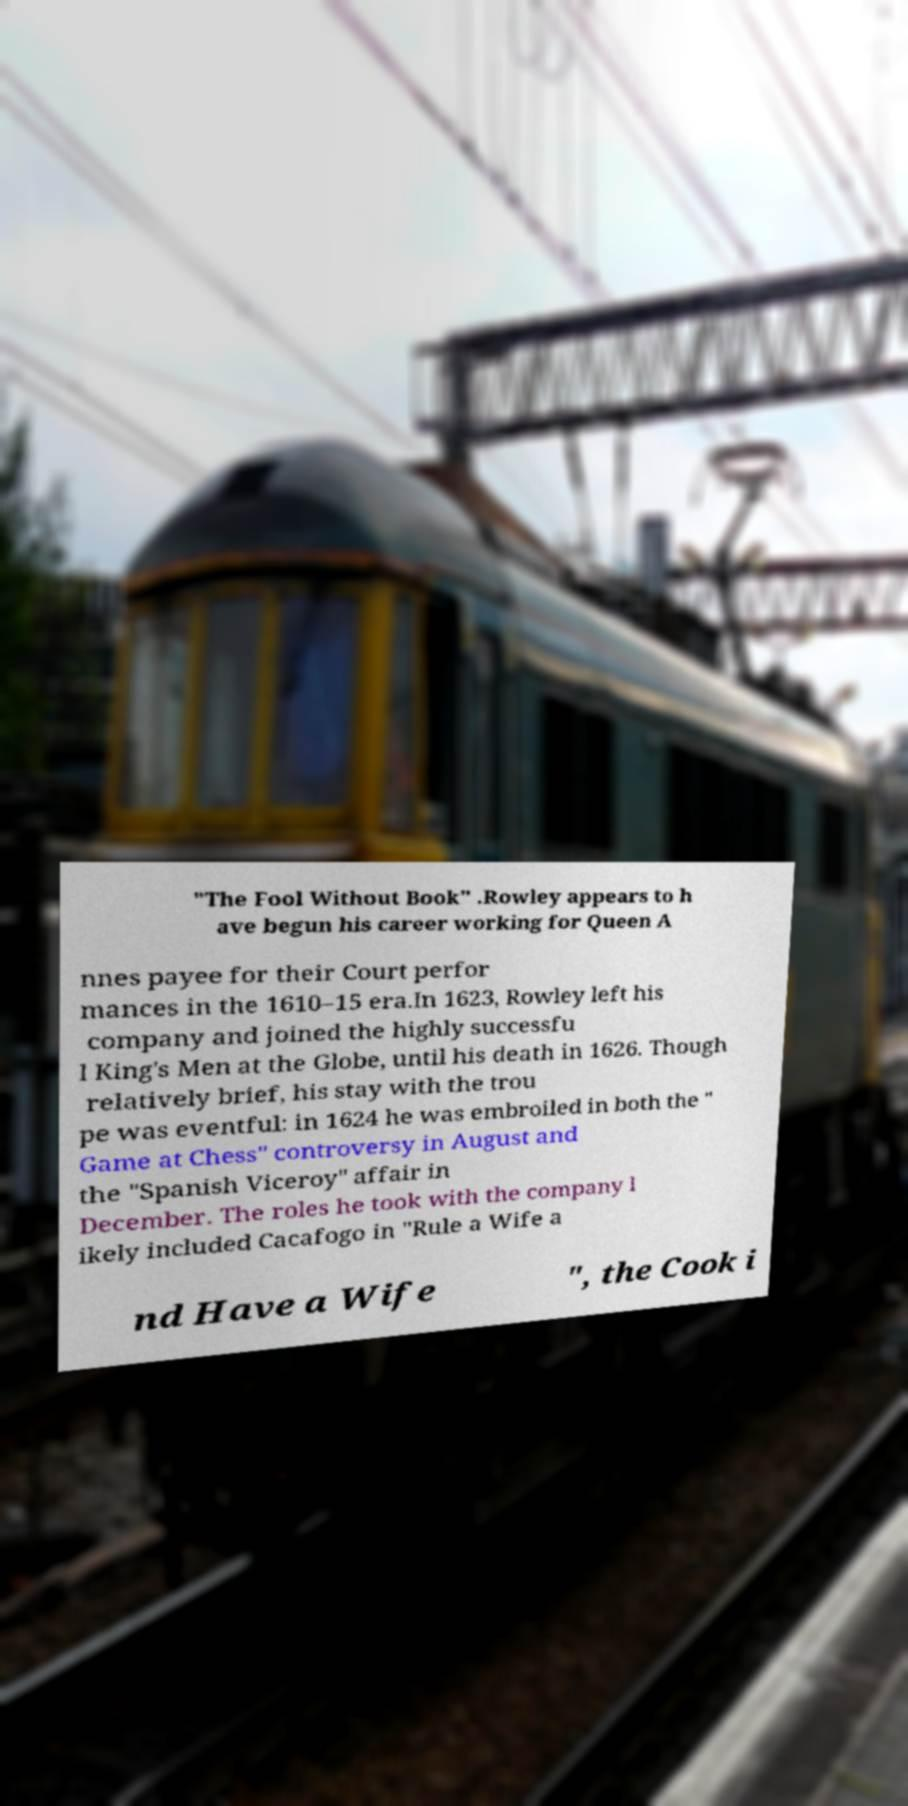For documentation purposes, I need the text within this image transcribed. Could you provide that? "The Fool Without Book" .Rowley appears to h ave begun his career working for Queen A nnes payee for their Court perfor mances in the 1610–15 era.In 1623, Rowley left his company and joined the highly successfu l King's Men at the Globe, until his death in 1626. Though relatively brief, his stay with the trou pe was eventful: in 1624 he was embroiled in both the " Game at Chess" controversy in August and the "Spanish Viceroy" affair in December. The roles he took with the company l ikely included Cacafogo in "Rule a Wife a nd Have a Wife ", the Cook i 